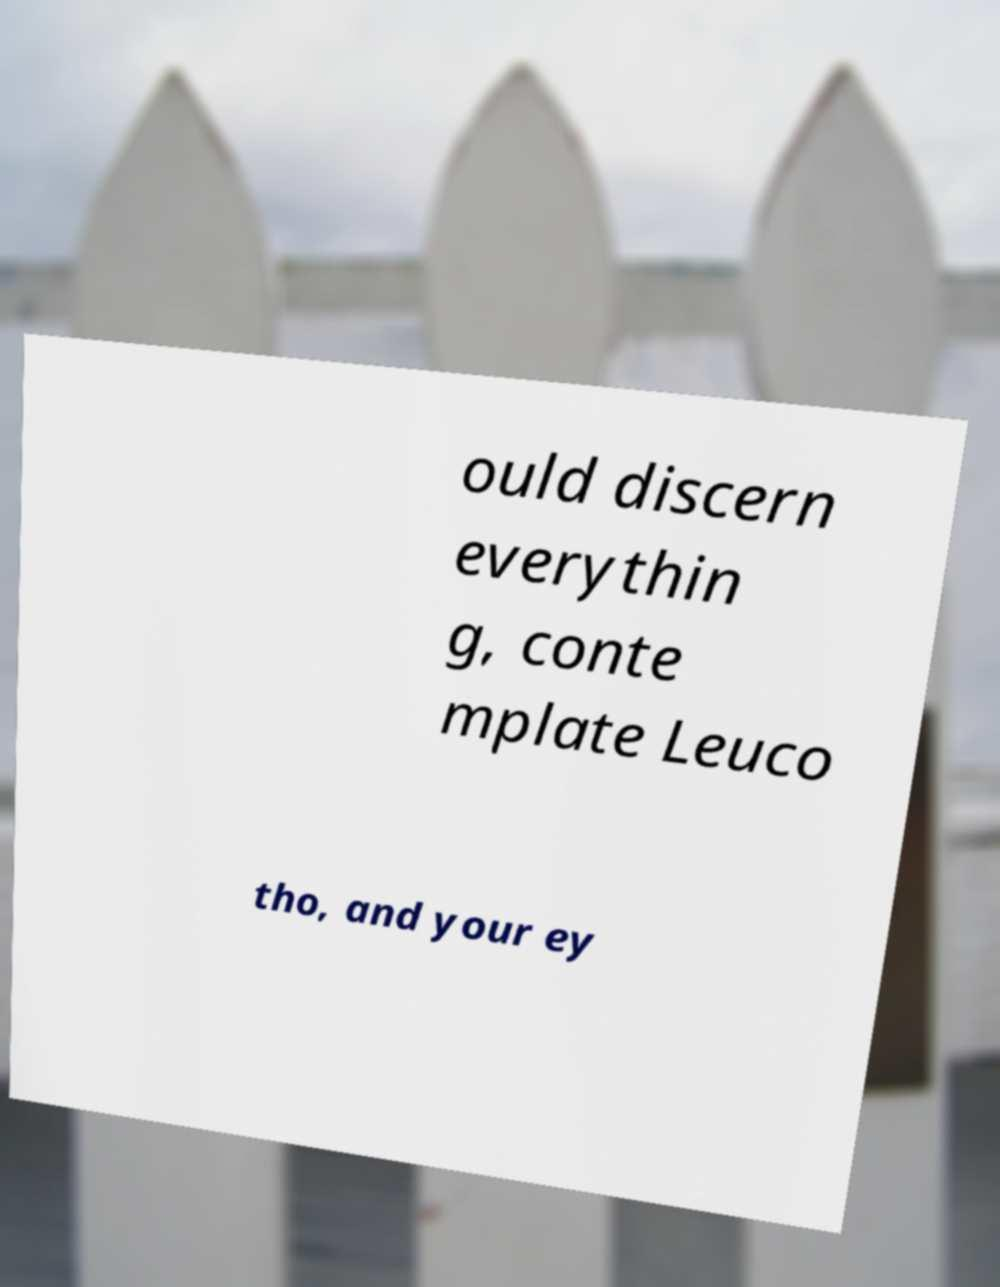Can you read and provide the text displayed in the image?This photo seems to have some interesting text. Can you extract and type it out for me? ould discern everythin g, conte mplate Leuco tho, and your ey 